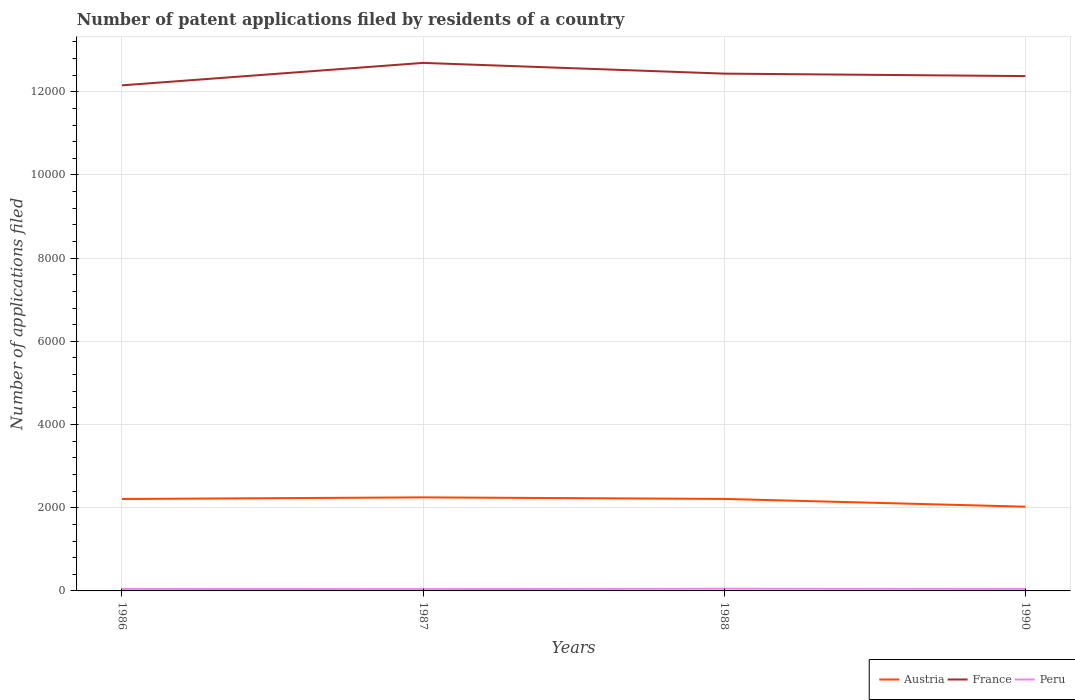How many different coloured lines are there?
Ensure brevity in your answer.  3. Does the line corresponding to Austria intersect with the line corresponding to France?
Give a very brief answer. No. Is the number of lines equal to the number of legend labels?
Give a very brief answer. Yes. Across all years, what is the maximum number of applications filed in France?
Offer a very short reply. 1.22e+04. What is the total number of applications filed in Austria in the graph?
Make the answer very short. 185. What is the difference between the highest and the second highest number of applications filed in France?
Your response must be concise. 540. What is the difference between two consecutive major ticks on the Y-axis?
Offer a very short reply. 2000. Does the graph contain any zero values?
Provide a succinct answer. No. Does the graph contain grids?
Provide a short and direct response. Yes. How many legend labels are there?
Provide a succinct answer. 3. What is the title of the graph?
Offer a terse response. Number of patent applications filed by residents of a country. What is the label or title of the X-axis?
Provide a succinct answer. Years. What is the label or title of the Y-axis?
Keep it short and to the point. Number of applications filed. What is the Number of applications filed in Austria in 1986?
Your answer should be very brief. 2210. What is the Number of applications filed of France in 1986?
Keep it short and to the point. 1.22e+04. What is the Number of applications filed of Austria in 1987?
Your answer should be very brief. 2249. What is the Number of applications filed of France in 1987?
Give a very brief answer. 1.27e+04. What is the Number of applications filed in Peru in 1987?
Ensure brevity in your answer.  43. What is the Number of applications filed of Austria in 1988?
Make the answer very short. 2212. What is the Number of applications filed in France in 1988?
Keep it short and to the point. 1.24e+04. What is the Number of applications filed of Austria in 1990?
Provide a succinct answer. 2025. What is the Number of applications filed in France in 1990?
Offer a terse response. 1.24e+04. What is the Number of applications filed in Peru in 1990?
Provide a short and direct response. 49. Across all years, what is the maximum Number of applications filed of Austria?
Provide a short and direct response. 2249. Across all years, what is the maximum Number of applications filed in France?
Your answer should be compact. 1.27e+04. Across all years, what is the maximum Number of applications filed in Peru?
Ensure brevity in your answer.  53. Across all years, what is the minimum Number of applications filed of Austria?
Provide a short and direct response. 2025. Across all years, what is the minimum Number of applications filed in France?
Give a very brief answer. 1.22e+04. Across all years, what is the minimum Number of applications filed in Peru?
Offer a very short reply. 43. What is the total Number of applications filed of Austria in the graph?
Keep it short and to the point. 8696. What is the total Number of applications filed in France in the graph?
Make the answer very short. 4.97e+04. What is the total Number of applications filed of Peru in the graph?
Give a very brief answer. 193. What is the difference between the Number of applications filed of Austria in 1986 and that in 1987?
Keep it short and to the point. -39. What is the difference between the Number of applications filed in France in 1986 and that in 1987?
Provide a succinct answer. -540. What is the difference between the Number of applications filed of Peru in 1986 and that in 1987?
Your response must be concise. 5. What is the difference between the Number of applications filed in Austria in 1986 and that in 1988?
Provide a succinct answer. -2. What is the difference between the Number of applications filed in France in 1986 and that in 1988?
Give a very brief answer. -282. What is the difference between the Number of applications filed of Austria in 1986 and that in 1990?
Your answer should be very brief. 185. What is the difference between the Number of applications filed in France in 1986 and that in 1990?
Offer a terse response. -223. What is the difference between the Number of applications filed in Peru in 1986 and that in 1990?
Your answer should be very brief. -1. What is the difference between the Number of applications filed in France in 1987 and that in 1988?
Provide a short and direct response. 258. What is the difference between the Number of applications filed of Peru in 1987 and that in 1988?
Provide a succinct answer. -10. What is the difference between the Number of applications filed of Austria in 1987 and that in 1990?
Your answer should be very brief. 224. What is the difference between the Number of applications filed of France in 1987 and that in 1990?
Provide a short and direct response. 317. What is the difference between the Number of applications filed of Peru in 1987 and that in 1990?
Offer a terse response. -6. What is the difference between the Number of applications filed of Austria in 1988 and that in 1990?
Provide a succinct answer. 187. What is the difference between the Number of applications filed of Austria in 1986 and the Number of applications filed of France in 1987?
Offer a terse response. -1.05e+04. What is the difference between the Number of applications filed in Austria in 1986 and the Number of applications filed in Peru in 1987?
Your response must be concise. 2167. What is the difference between the Number of applications filed in France in 1986 and the Number of applications filed in Peru in 1987?
Your response must be concise. 1.21e+04. What is the difference between the Number of applications filed of Austria in 1986 and the Number of applications filed of France in 1988?
Keep it short and to the point. -1.02e+04. What is the difference between the Number of applications filed in Austria in 1986 and the Number of applications filed in Peru in 1988?
Offer a very short reply. 2157. What is the difference between the Number of applications filed in France in 1986 and the Number of applications filed in Peru in 1988?
Your answer should be very brief. 1.21e+04. What is the difference between the Number of applications filed in Austria in 1986 and the Number of applications filed in France in 1990?
Provide a succinct answer. -1.02e+04. What is the difference between the Number of applications filed in Austria in 1986 and the Number of applications filed in Peru in 1990?
Your answer should be very brief. 2161. What is the difference between the Number of applications filed in France in 1986 and the Number of applications filed in Peru in 1990?
Make the answer very short. 1.21e+04. What is the difference between the Number of applications filed of Austria in 1987 and the Number of applications filed of France in 1988?
Offer a very short reply. -1.02e+04. What is the difference between the Number of applications filed of Austria in 1987 and the Number of applications filed of Peru in 1988?
Provide a succinct answer. 2196. What is the difference between the Number of applications filed of France in 1987 and the Number of applications filed of Peru in 1988?
Provide a succinct answer. 1.26e+04. What is the difference between the Number of applications filed of Austria in 1987 and the Number of applications filed of France in 1990?
Provide a succinct answer. -1.01e+04. What is the difference between the Number of applications filed of Austria in 1987 and the Number of applications filed of Peru in 1990?
Offer a terse response. 2200. What is the difference between the Number of applications filed in France in 1987 and the Number of applications filed in Peru in 1990?
Give a very brief answer. 1.26e+04. What is the difference between the Number of applications filed of Austria in 1988 and the Number of applications filed of France in 1990?
Make the answer very short. -1.02e+04. What is the difference between the Number of applications filed in Austria in 1988 and the Number of applications filed in Peru in 1990?
Your answer should be very brief. 2163. What is the difference between the Number of applications filed of France in 1988 and the Number of applications filed of Peru in 1990?
Ensure brevity in your answer.  1.24e+04. What is the average Number of applications filed in Austria per year?
Keep it short and to the point. 2174. What is the average Number of applications filed in France per year?
Make the answer very short. 1.24e+04. What is the average Number of applications filed in Peru per year?
Your answer should be compact. 48.25. In the year 1986, what is the difference between the Number of applications filed of Austria and Number of applications filed of France?
Keep it short and to the point. -9945. In the year 1986, what is the difference between the Number of applications filed of Austria and Number of applications filed of Peru?
Provide a succinct answer. 2162. In the year 1986, what is the difference between the Number of applications filed of France and Number of applications filed of Peru?
Your answer should be very brief. 1.21e+04. In the year 1987, what is the difference between the Number of applications filed in Austria and Number of applications filed in France?
Your answer should be compact. -1.04e+04. In the year 1987, what is the difference between the Number of applications filed of Austria and Number of applications filed of Peru?
Ensure brevity in your answer.  2206. In the year 1987, what is the difference between the Number of applications filed in France and Number of applications filed in Peru?
Keep it short and to the point. 1.27e+04. In the year 1988, what is the difference between the Number of applications filed in Austria and Number of applications filed in France?
Keep it short and to the point. -1.02e+04. In the year 1988, what is the difference between the Number of applications filed of Austria and Number of applications filed of Peru?
Provide a short and direct response. 2159. In the year 1988, what is the difference between the Number of applications filed of France and Number of applications filed of Peru?
Ensure brevity in your answer.  1.24e+04. In the year 1990, what is the difference between the Number of applications filed of Austria and Number of applications filed of France?
Your response must be concise. -1.04e+04. In the year 1990, what is the difference between the Number of applications filed in Austria and Number of applications filed in Peru?
Offer a terse response. 1976. In the year 1990, what is the difference between the Number of applications filed in France and Number of applications filed in Peru?
Your response must be concise. 1.23e+04. What is the ratio of the Number of applications filed of Austria in 1986 to that in 1987?
Your answer should be very brief. 0.98. What is the ratio of the Number of applications filed of France in 1986 to that in 1987?
Give a very brief answer. 0.96. What is the ratio of the Number of applications filed of Peru in 1986 to that in 1987?
Keep it short and to the point. 1.12. What is the ratio of the Number of applications filed of Austria in 1986 to that in 1988?
Make the answer very short. 1. What is the ratio of the Number of applications filed in France in 1986 to that in 1988?
Keep it short and to the point. 0.98. What is the ratio of the Number of applications filed in Peru in 1986 to that in 1988?
Provide a short and direct response. 0.91. What is the ratio of the Number of applications filed of Austria in 1986 to that in 1990?
Your response must be concise. 1.09. What is the ratio of the Number of applications filed in France in 1986 to that in 1990?
Your answer should be compact. 0.98. What is the ratio of the Number of applications filed in Peru in 1986 to that in 1990?
Give a very brief answer. 0.98. What is the ratio of the Number of applications filed in Austria in 1987 to that in 1988?
Your response must be concise. 1.02. What is the ratio of the Number of applications filed of France in 1987 to that in 1988?
Your answer should be very brief. 1.02. What is the ratio of the Number of applications filed in Peru in 1987 to that in 1988?
Make the answer very short. 0.81. What is the ratio of the Number of applications filed of Austria in 1987 to that in 1990?
Make the answer very short. 1.11. What is the ratio of the Number of applications filed in France in 1987 to that in 1990?
Your response must be concise. 1.03. What is the ratio of the Number of applications filed of Peru in 1987 to that in 1990?
Ensure brevity in your answer.  0.88. What is the ratio of the Number of applications filed in Austria in 1988 to that in 1990?
Keep it short and to the point. 1.09. What is the ratio of the Number of applications filed of France in 1988 to that in 1990?
Ensure brevity in your answer.  1. What is the ratio of the Number of applications filed of Peru in 1988 to that in 1990?
Ensure brevity in your answer.  1.08. What is the difference between the highest and the second highest Number of applications filed in Austria?
Ensure brevity in your answer.  37. What is the difference between the highest and the second highest Number of applications filed in France?
Offer a terse response. 258. What is the difference between the highest and the second highest Number of applications filed of Peru?
Offer a terse response. 4. What is the difference between the highest and the lowest Number of applications filed of Austria?
Your answer should be very brief. 224. What is the difference between the highest and the lowest Number of applications filed in France?
Ensure brevity in your answer.  540. What is the difference between the highest and the lowest Number of applications filed in Peru?
Provide a succinct answer. 10. 